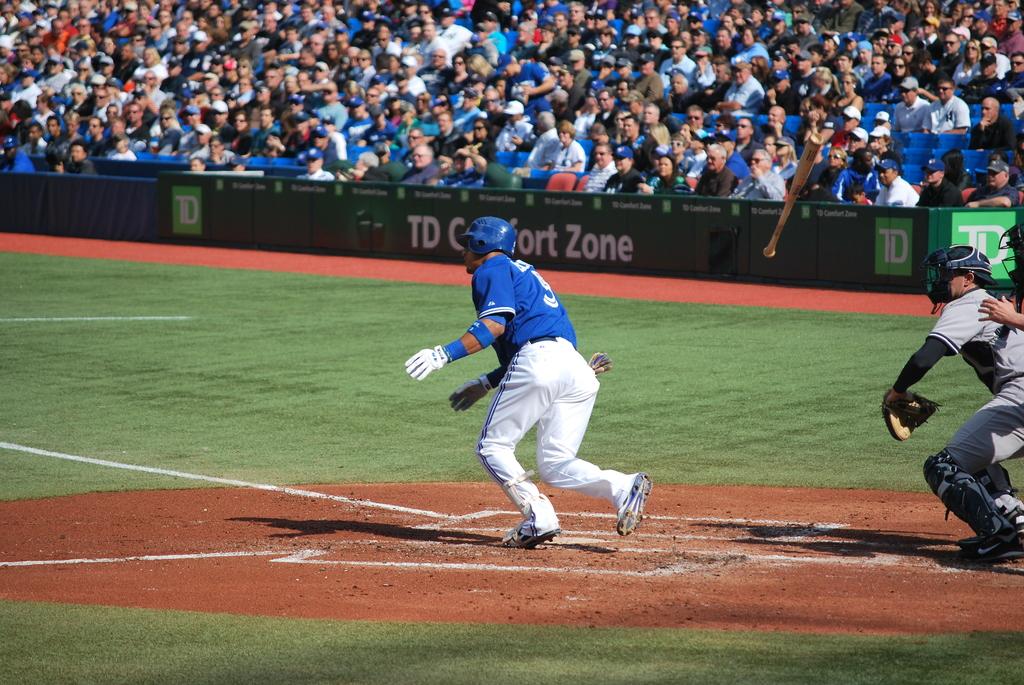Which bank is advertised on the sign?
Provide a succinct answer. Td. What is the number on the player's jersey?
Ensure brevity in your answer.  5. 